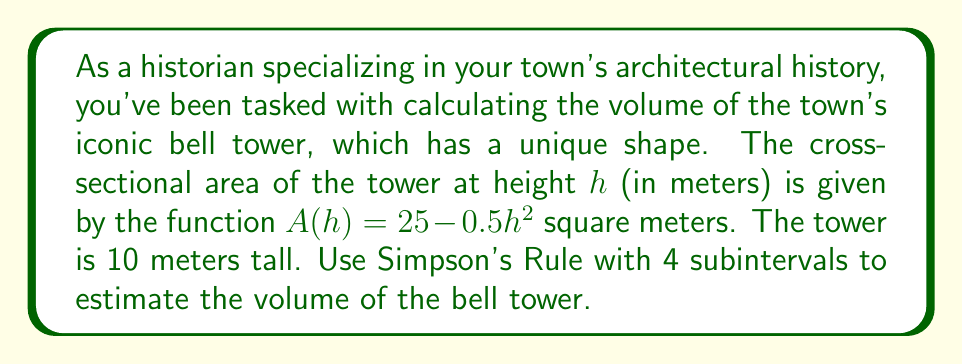Teach me how to tackle this problem. To solve this problem, we'll use Simpson's Rule for numerical integration. The steps are as follows:

1) The volume of a solid with variable cross-sectional area is given by:

   $$V = \int_0^H A(h) dh$$

   where $H$ is the height of the solid and $A(h)$ is the cross-sectional area function.

2) Simpson's Rule for 4 subintervals is:

   $$\int_a^b f(x) dx \approx \frac{b-a}{12} [f(x_0) + 4f(x_1) + 2f(x_2) + 4f(x_3) + f(x_4)]$$

3) In our case, $a=0$, $b=10$, and $f(h) = A(h) = 25 - 0.5h^2$

4) We need to calculate $h$ and $f(h)$ at 5 points:

   $h_0 = 0$,   $f(h_0) = 25 - 0.5(0)^2 = 25$
   $h_1 = 2.5$, $f(h_1) = 25 - 0.5(2.5)^2 = 21.875$
   $h_2 = 5$,   $f(h_2) = 25 - 0.5(5)^2 = 12.5$
   $h_3 = 7.5$, $f(h_3) = 25 - 0.5(7.5)^2 = -3.125$
   $h_4 = 10$,  $f(h_4) = 25 - 0.5(10)^2 = -25$

5) Applying Simpson's Rule:

   $$V \approx \frac{10-0}{12} [25 + 4(21.875) + 2(12.5) + 4(-3.125) + (-25)]$$

6) Simplifying:

   $$V \approx \frac{10}{12} [25 + 87.5 + 25 - 12.5 - 25] = \frac{10}{12} (100) = 83.33$$

Therefore, the estimated volume of the bell tower is approximately 83.33 cubic meters.
Answer: 83.33 m³ 